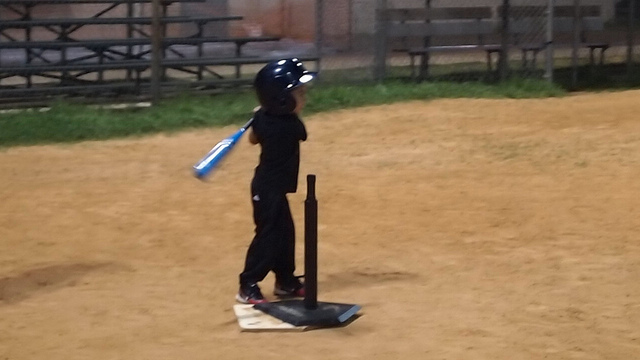What skills could this child be learning through playing baseball? Playing baseball, the child is likely learning a variety of skills, such as teamwork, hand-eye coordination, sportsmanship, strategic thinking, and discipline. The sport also teaches patience and persistence, as hitting a baseball is often considered one of the most challenging skills to master in sports. What are the benefits of starting to play a sport at such a young age? Starting a sport at a young age can have numerous benefits for children. It helps in physical development, building strong bones and muscles, improving cardiovascular fitness, and enhancing flexibility. It also contributes to the development of social skills through interaction with teammates and coaches, as well as emotional skills, such as confidence, self-esteem, and the ability to handle success and disappointment. 